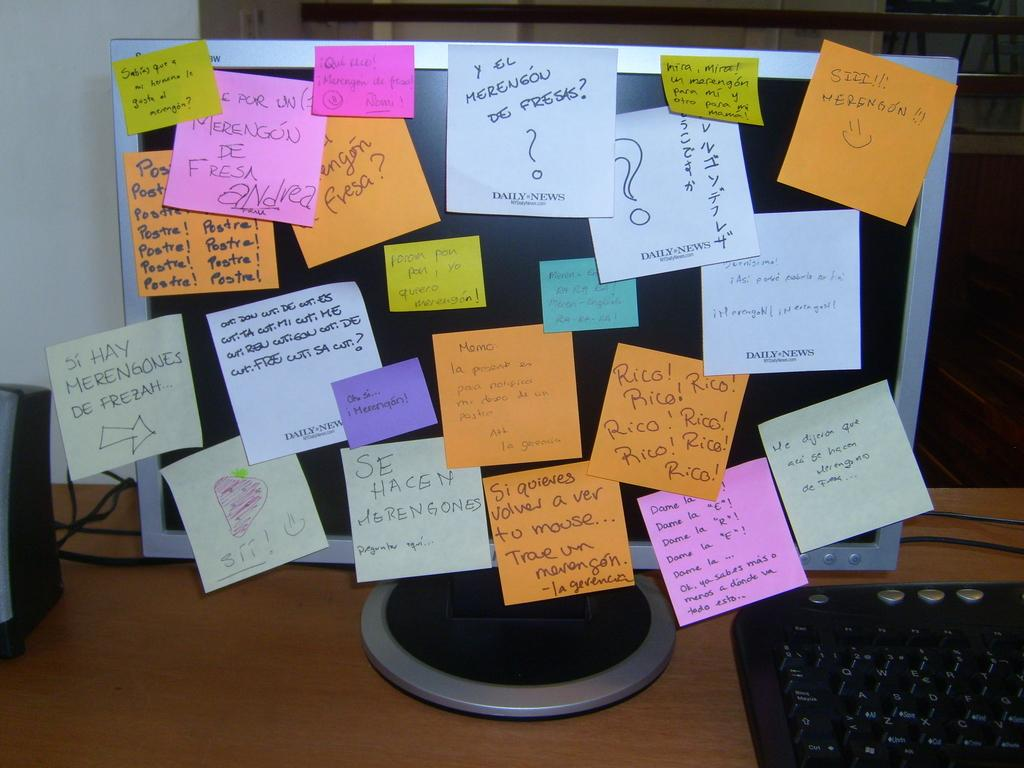<image>
Provide a brief description of the given image. a computer screen with post it notes all over it with one of them saying 'que rico! 